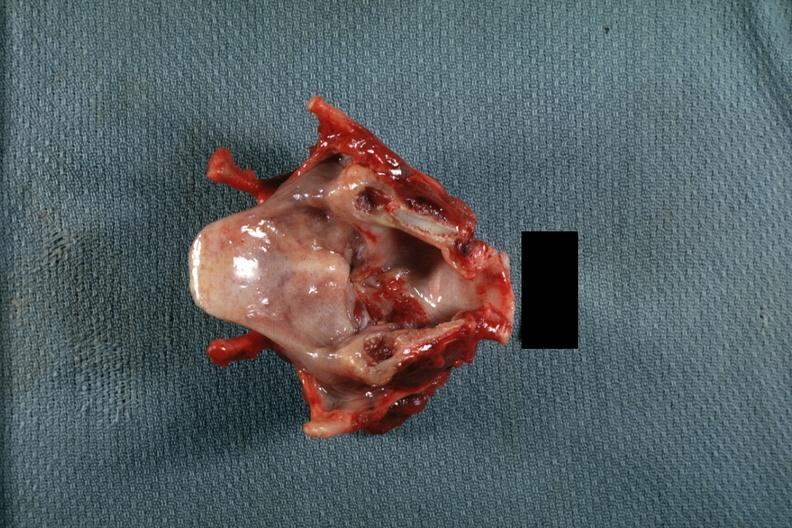does this image show excellent lesion on true cord spreading down?
Answer the question using a single word or phrase. Yes 